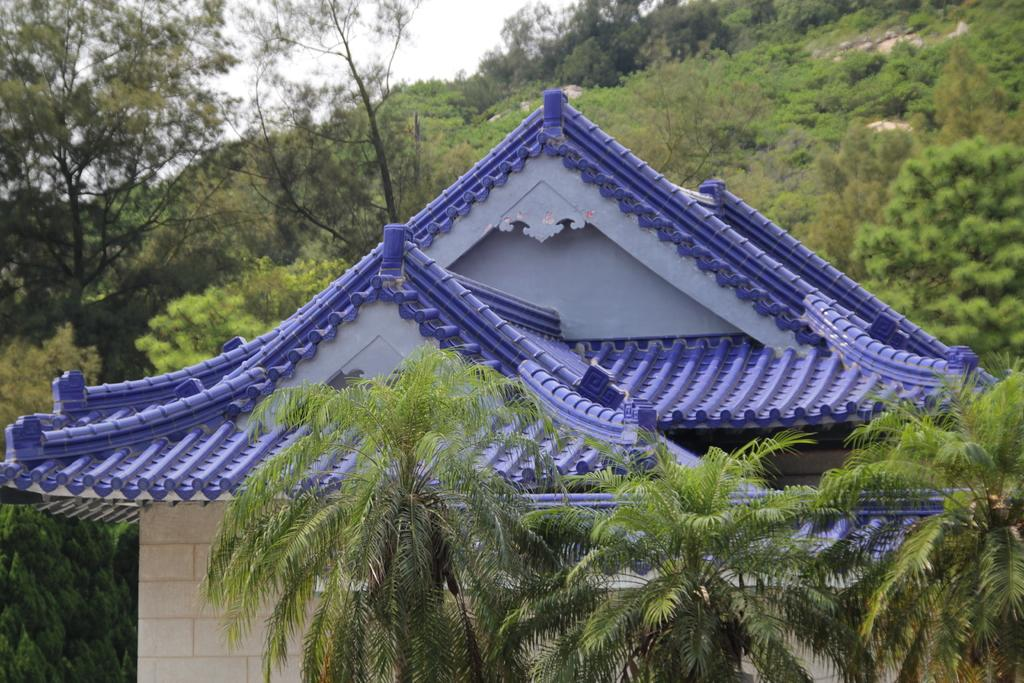How many trees are in the foreground of the image? There are three trees in the foreground of the image. What structure is located behind the trees in the image? There is a house behind the trees in the image. What can be seen in the background of the image besides the sky? There are trees visible in the background of the image. What is visible at the top of the image? The sky is visible in the background of the image. What type of soup is being served in the image? There is no soup present in the image; it features three trees in the foreground, a house behind the trees, and trees and the sky visible in the background. Can you tell me how many leaves are on the trees in the image? The number of leaves on the trees cannot be determined from the image, as the focus is on the trees themselves and not their individual leaves. 